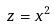<formula> <loc_0><loc_0><loc_500><loc_500>z = x ^ { 2 }</formula> 